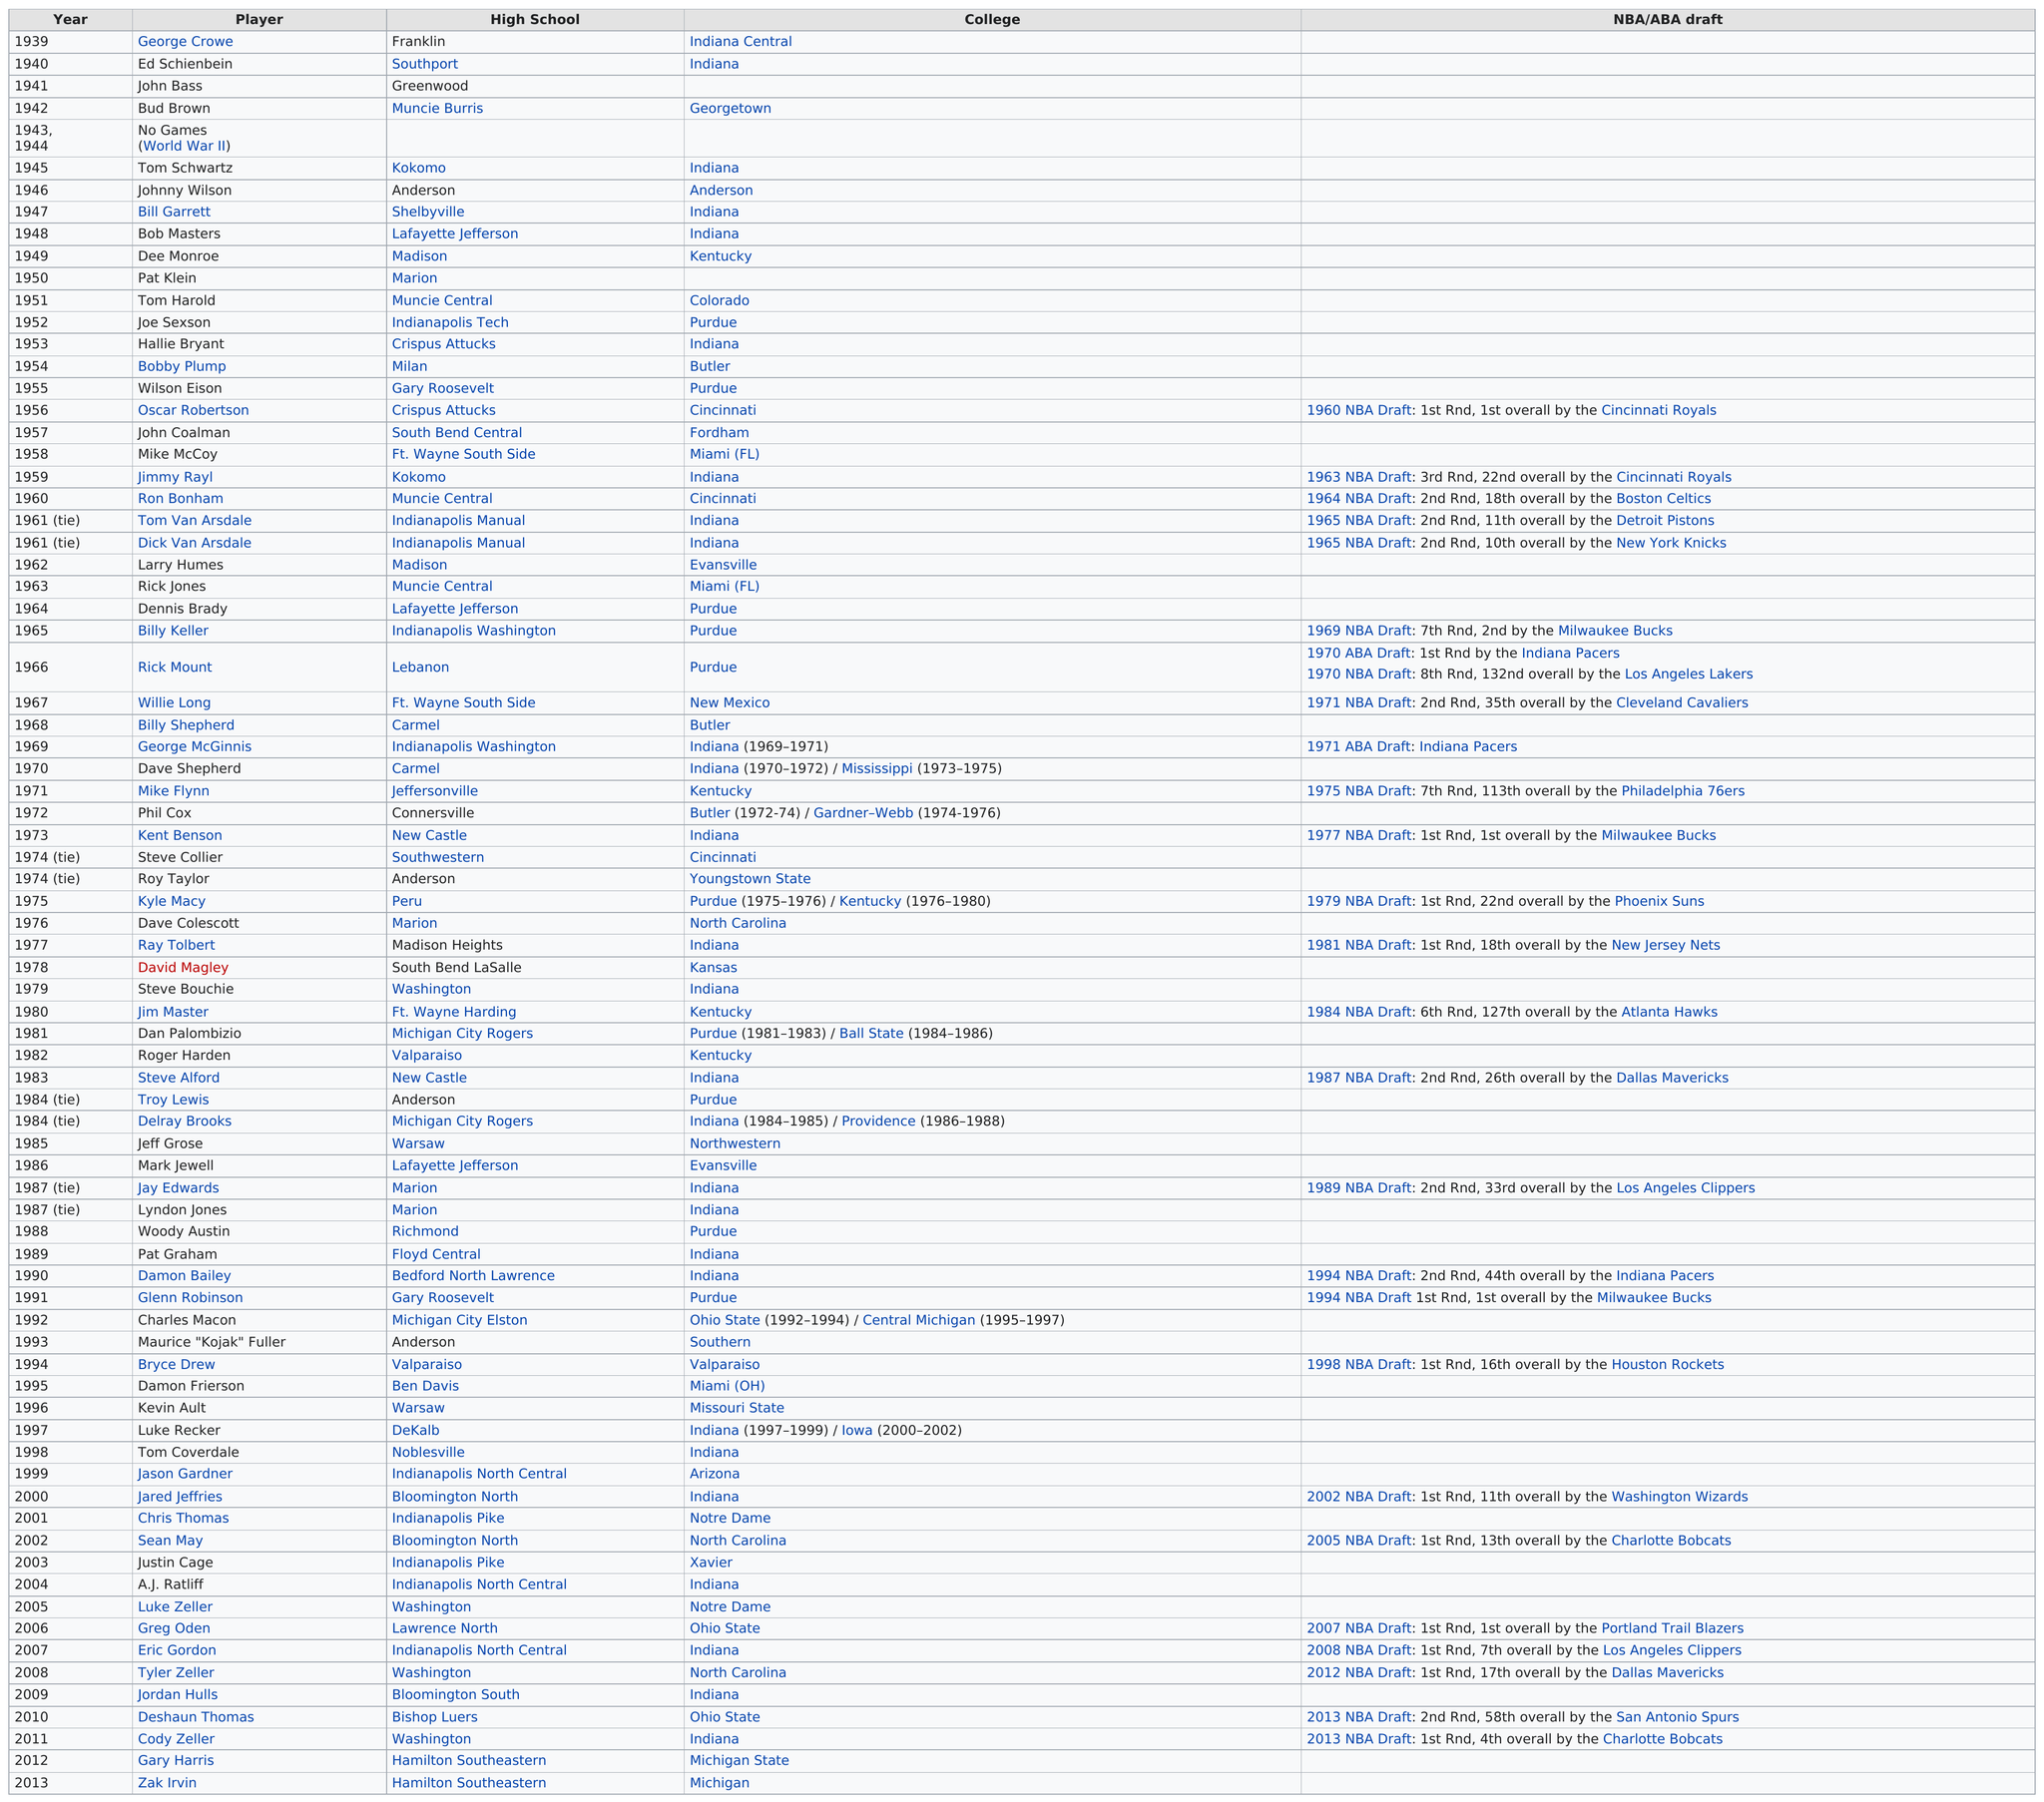Identify some key points in this picture. Zak Irvin won the last one. A significant number of players from Notre Dame have attended the university, including two. During the years 1950-60, a total of two award winners from Purdue University were recognized for their accomplishments. Kent Benson and Glenn Robinson, both acclaimed award winners, were selected by the Milwaukee Bucks in the NBA draft, It is known that prior to Ed Schienbein winning an award in 1940, George Crowe had already received an award in the same year. 